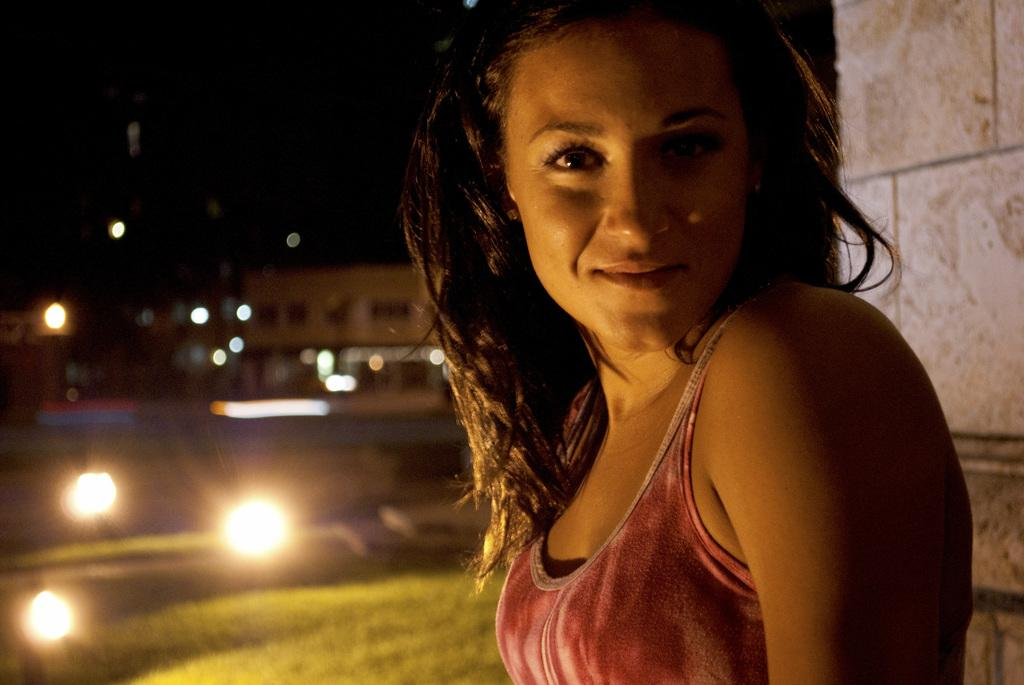Who is present in the image? There is a woman in the image. What is the woman's facial expression? The woman is smiling. What is located beside the woman? There is a wall beside the woman. Can you describe the background of the image? The background of the image is blurry, and there is a building, lights, and grass visible. How many beds are visible in the image? There are no beds present in the image. What type of hands can be seen holding the lights in the image? There are no hands visible in the image, and the lights are part of the background. 